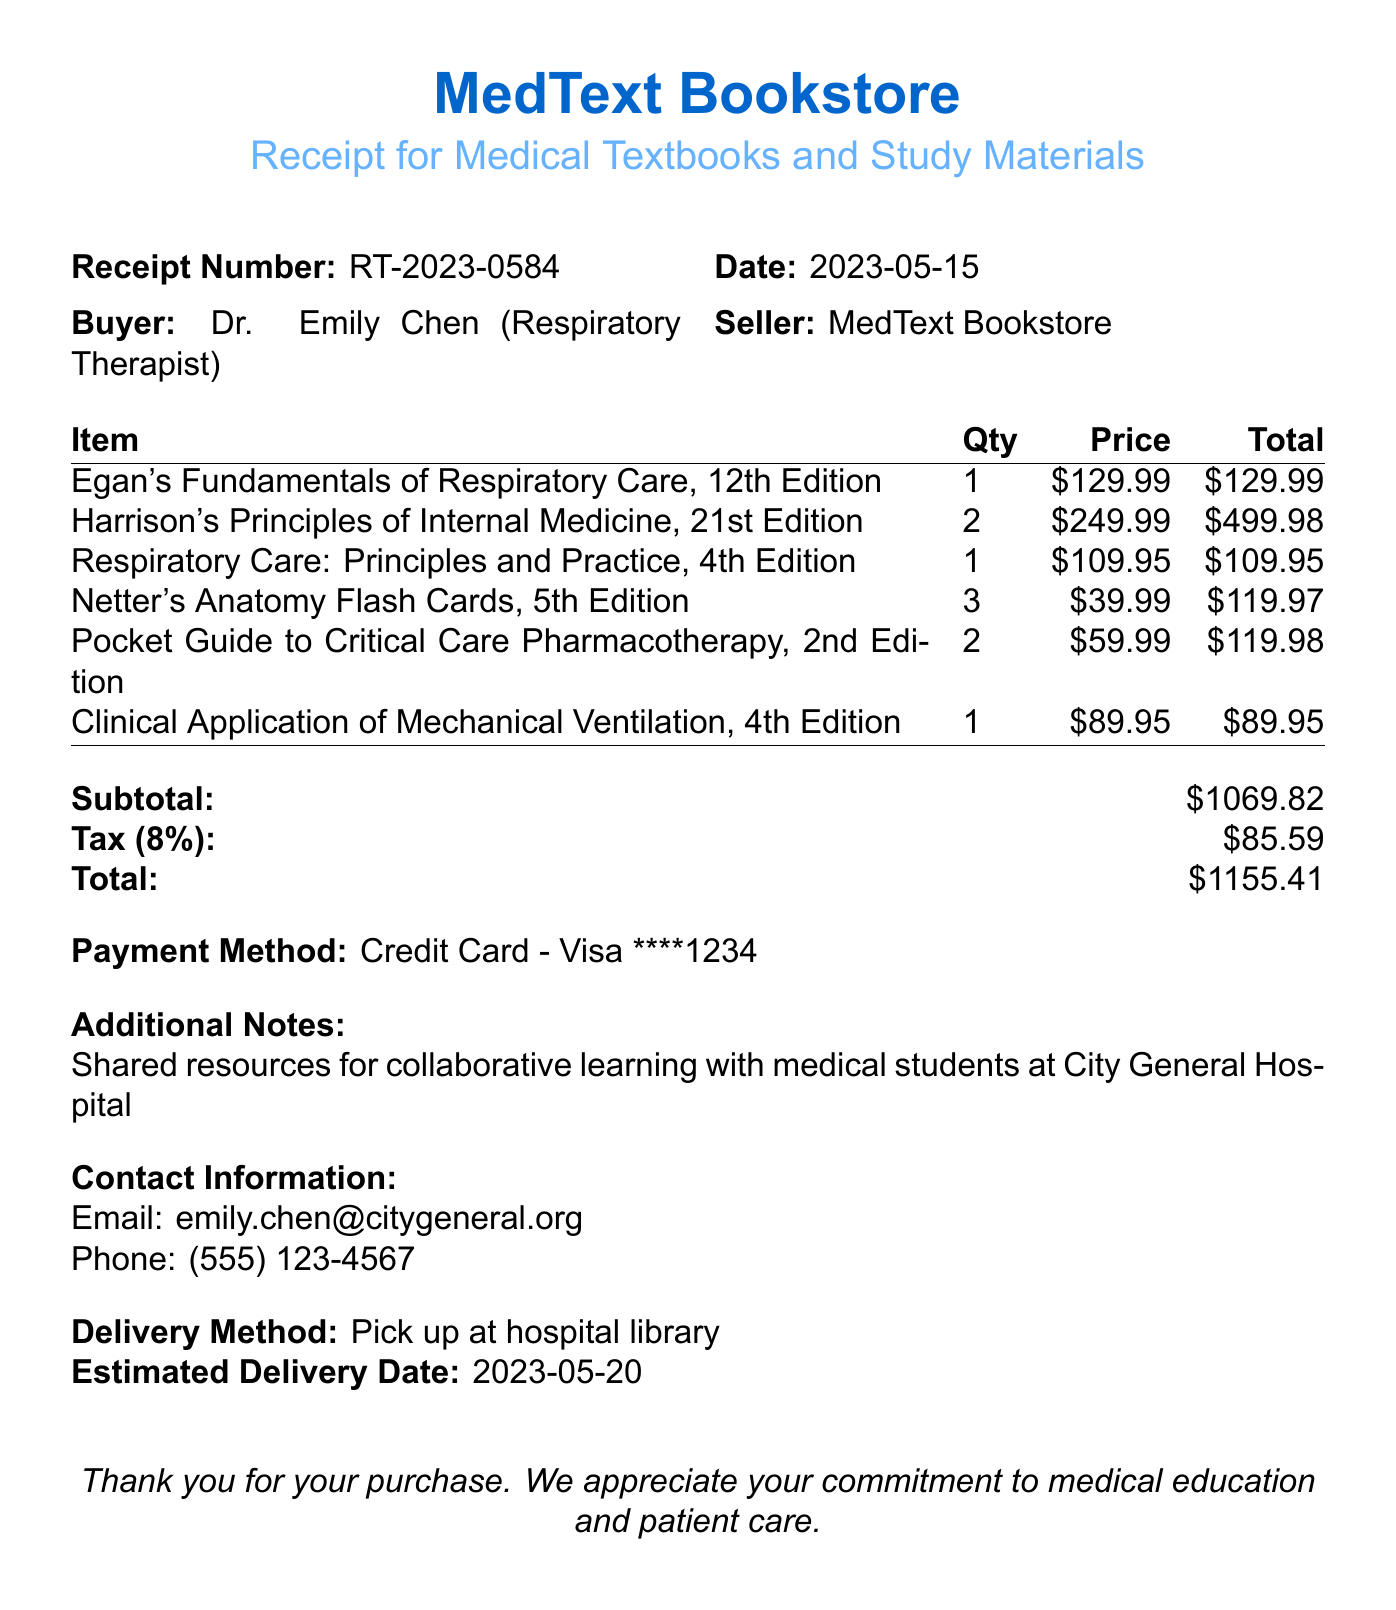What is the receipt number? The receipt number is clearly stated in the document, which is RT-2023-0584.
Answer: RT-2023-0584 Who is the buyer? The document specifies that the buyer is Dr. Emily Chen, a respiratory therapist.
Answer: Dr. Emily Chen What is the total amount? The total amount is found by summing the subtotal and tax, which equals $1155.41.
Answer: $1155.41 How many copies of "Harrison's Principles of Internal Medicine" were purchased? The document lists the quantity of this book, which is 2.
Answer: 2 What is the delivery method for the items? The delivery method is explicitly mentioned in the document as 'Pick up at hospital library.'
Answer: Pick up at hospital library What is the tax amount? The tax amount is indicated in the document and calculated as $85.59.
Answer: $85.59 What are the additional notes regarding the purchase? The additional notes outline the purpose of the purchase, which is collaborative learning with medical students.
Answer: Shared resources for collaborative learning with medical students at City General Hospital What is the payment method used? The payment method is detailed in the receipt and is indicated as a credit card payment.
Answer: Credit Card - Visa ****1234 What is the estimated delivery date? The estimated delivery date is mentioned in the document as May 20, 2023.
Answer: 2023-05-20 